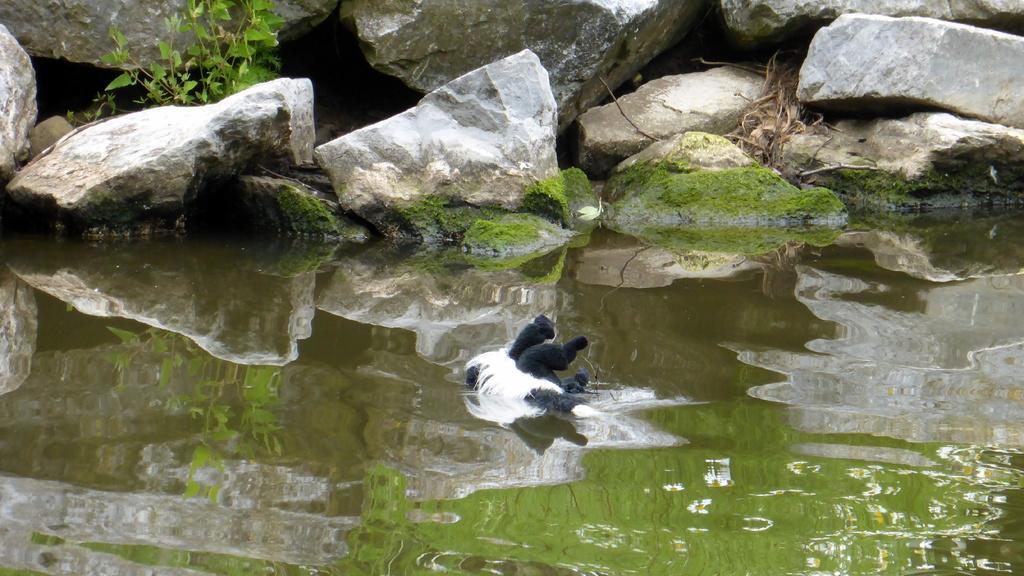Please provide a concise description of this image. Here we can see an animal and water. In the background we can see a plant and rocks. 